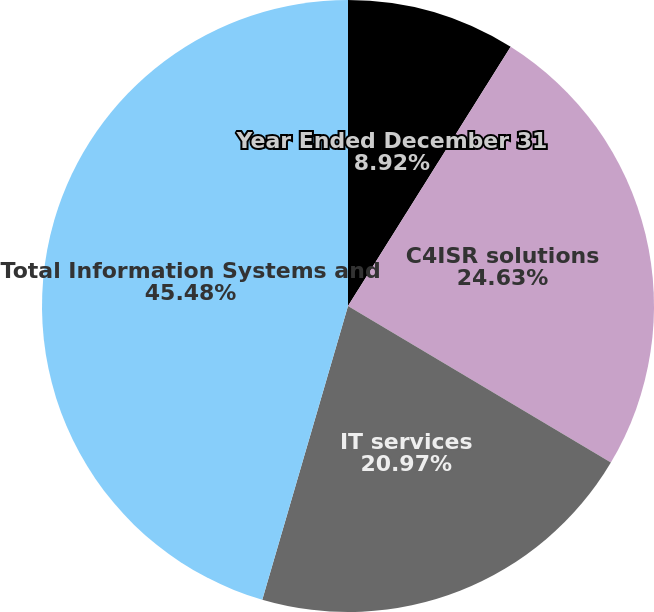<chart> <loc_0><loc_0><loc_500><loc_500><pie_chart><fcel>Year Ended December 31<fcel>C4ISR solutions<fcel>IT services<fcel>Total Information Systems and<nl><fcel>8.92%<fcel>24.63%<fcel>20.97%<fcel>45.48%<nl></chart> 